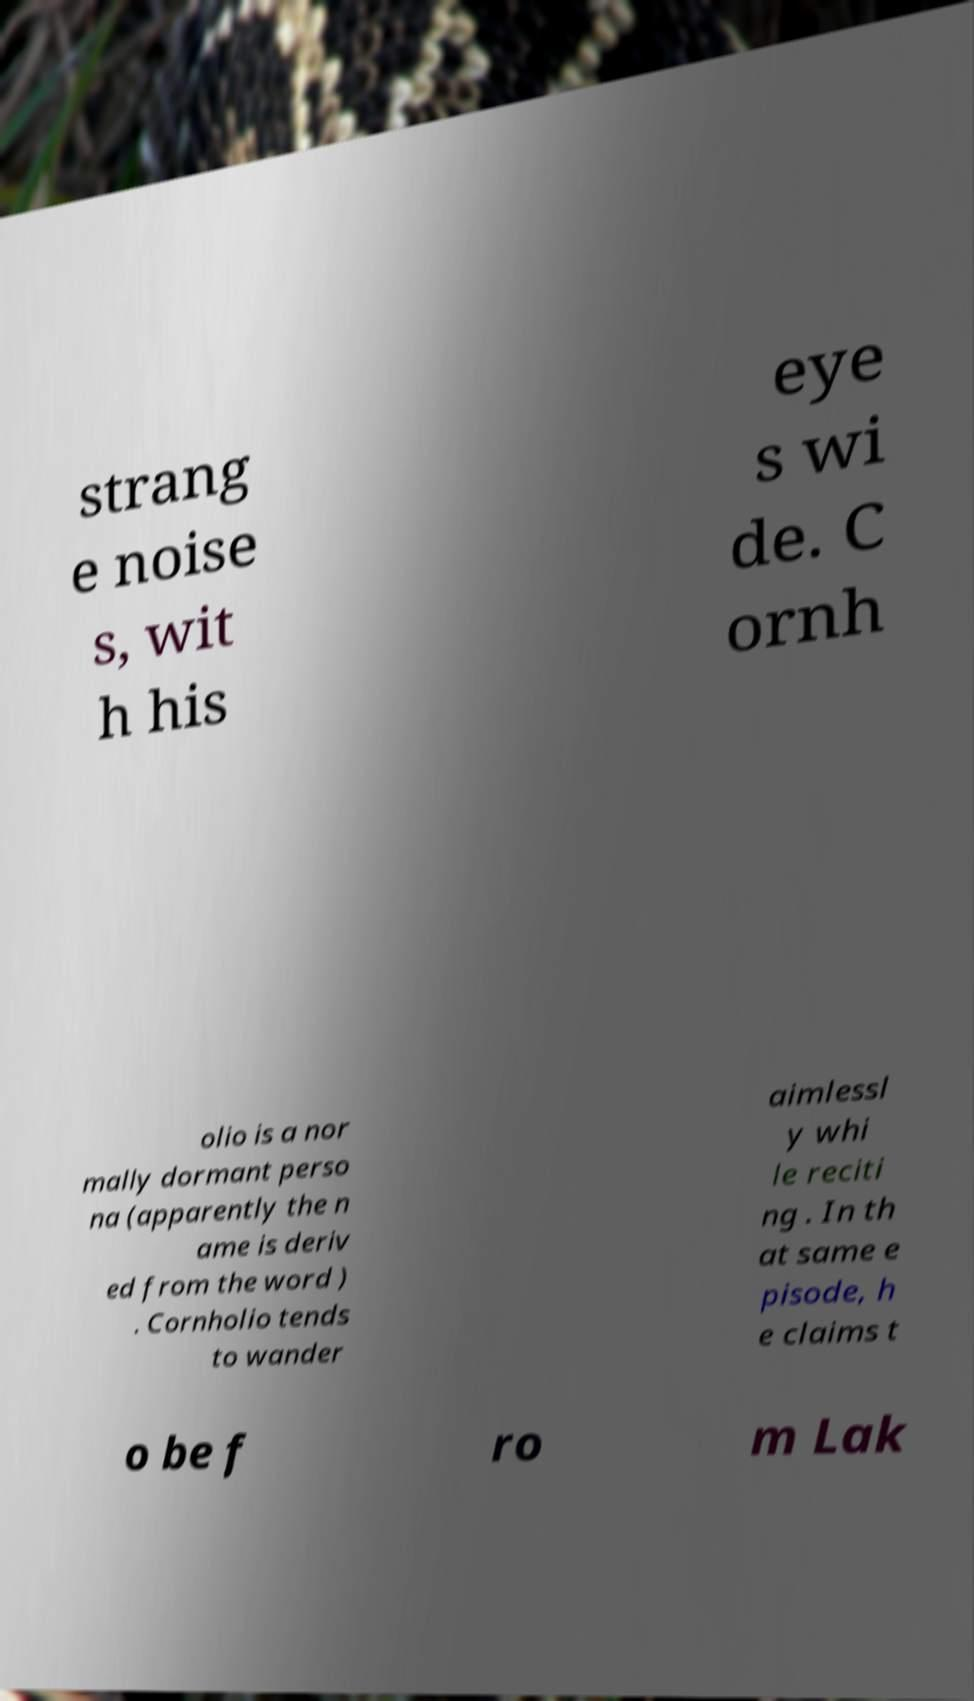What messages or text are displayed in this image? I need them in a readable, typed format. strang e noise s, wit h his eye s wi de. C ornh olio is a nor mally dormant perso na (apparently the n ame is deriv ed from the word ) . Cornholio tends to wander aimlessl y whi le reciti ng . In th at same e pisode, h e claims t o be f ro m Lak 